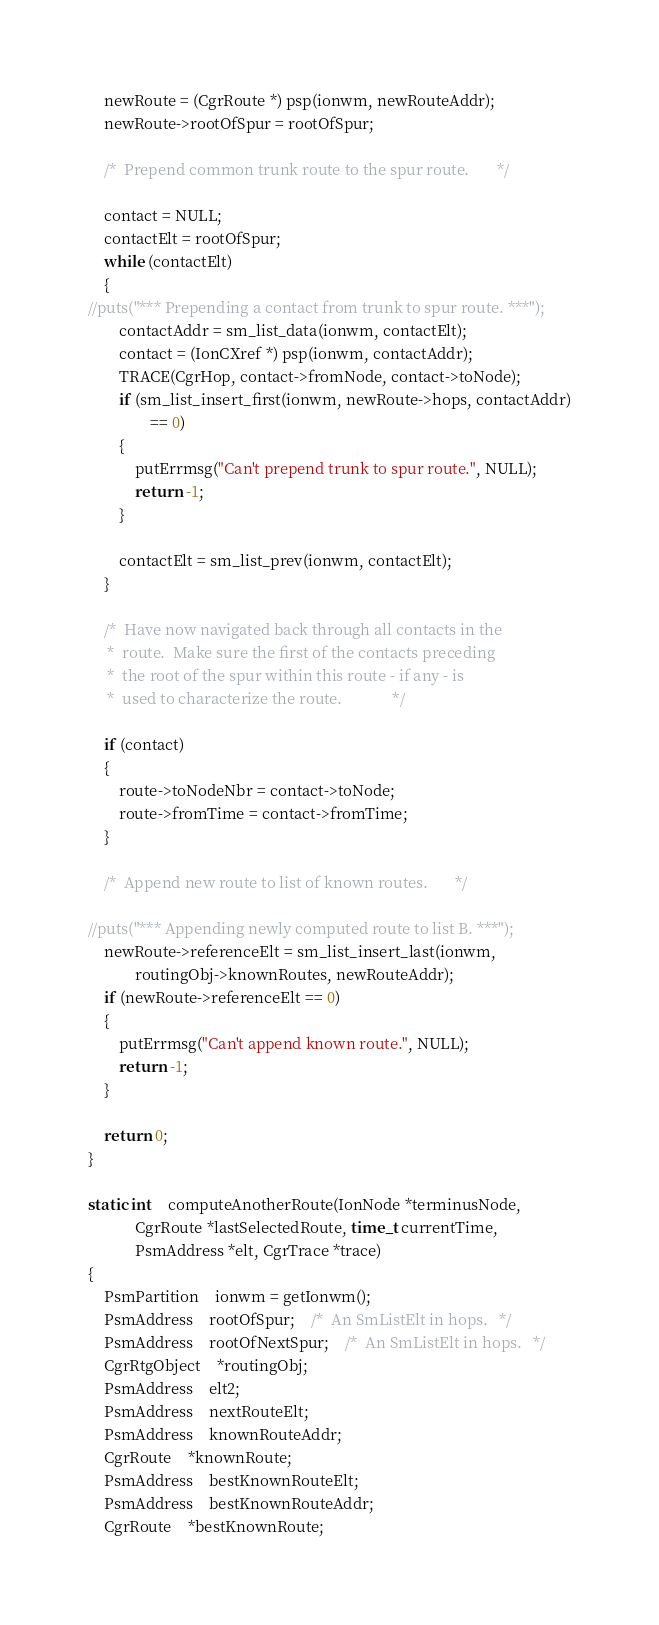Convert code to text. <code><loc_0><loc_0><loc_500><loc_500><_C_>	newRoute = (CgrRoute *) psp(ionwm, newRouteAddr);
	newRoute->rootOfSpur = rootOfSpur;

	/*	Prepend common trunk route to the spur route.		*/

	contact = NULL;
	contactElt = rootOfSpur;
	while (contactElt)
	{
//puts("*** Prepending a contact from trunk to spur route. ***");
		contactAddr = sm_list_data(ionwm, contactElt);
		contact = (IonCXref *) psp(ionwm, contactAddr);
		TRACE(CgrHop, contact->fromNode, contact->toNode);
		if (sm_list_insert_first(ionwm, newRoute->hops, contactAddr)
				== 0)
		{
			putErrmsg("Can't prepend trunk to spur route.", NULL);
			return -1;
		}

		contactElt = sm_list_prev(ionwm, contactElt);
	}

	/*	Have now navigated back through all contacts in the
	 *	route.  Make sure the first of the contacts preceding
	 *	the root of the spur within this route - if any - is
	 *	used to characterize the route.				*/

	if (contact)
	{
		route->toNodeNbr = contact->toNode;
		route->fromTime = contact->fromTime;
	}

	/*	Append new route to list of known routes.		*/

//puts("*** Appending newly computed route to list B. ***");
	newRoute->referenceElt = sm_list_insert_last(ionwm,
			routingObj->knownRoutes, newRouteAddr);
	if (newRoute->referenceElt == 0)
	{
		putErrmsg("Can't append known route.", NULL);
		return -1;
	}

	return 0;
}

static int	computeAnotherRoute(IonNode *terminusNode,
			CgrRoute *lastSelectedRoute, time_t currentTime,
			PsmAddress *elt, CgrTrace *trace)
{
	PsmPartition	ionwm = getIonwm();
	PsmAddress	rootOfSpur;	/*	An SmListElt in hops.	*/
	PsmAddress	rootOfNextSpur;	/*	An SmListElt in hops.	*/
	CgrRtgObject	*routingObj;
	PsmAddress	elt2;
	PsmAddress	nextRouteElt;
	PsmAddress	knownRouteAddr;
	CgrRoute	*knownRoute;
	PsmAddress	bestKnownRouteElt;
	PsmAddress	bestKnownRouteAddr;
	CgrRoute	*bestKnownRoute;
</code> 